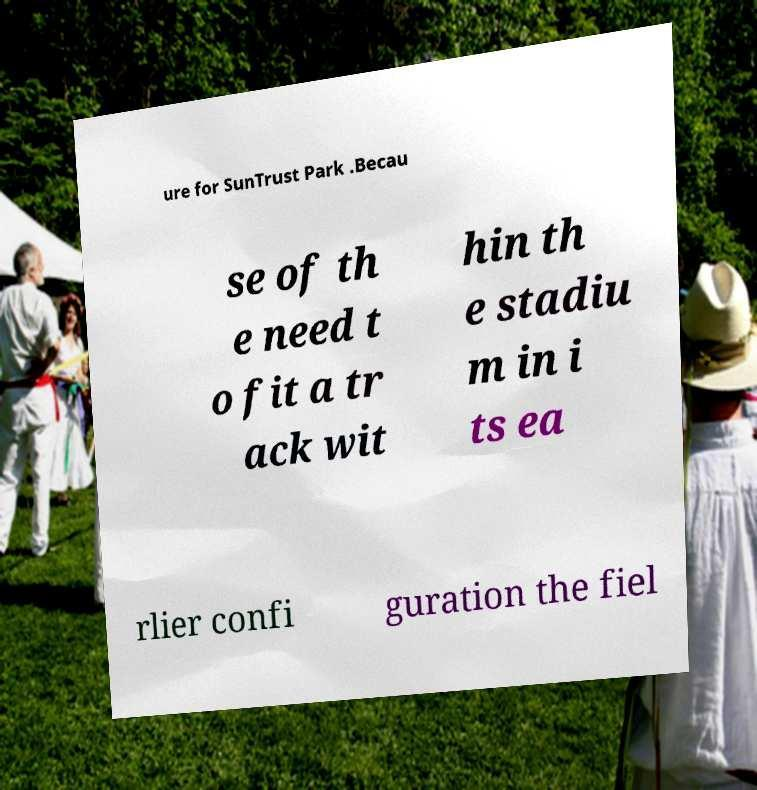Please read and relay the text visible in this image. What does it say? ure for SunTrust Park .Becau se of th e need t o fit a tr ack wit hin th e stadiu m in i ts ea rlier confi guration the fiel 